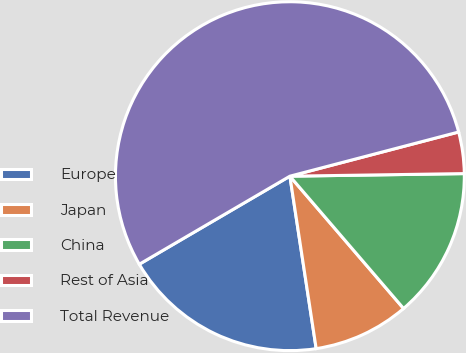Convert chart. <chart><loc_0><loc_0><loc_500><loc_500><pie_chart><fcel>Europe<fcel>Japan<fcel>China<fcel>Rest of Asia<fcel>Total Revenue<nl><fcel>18.99%<fcel>8.89%<fcel>13.94%<fcel>3.84%<fcel>54.35%<nl></chart> 